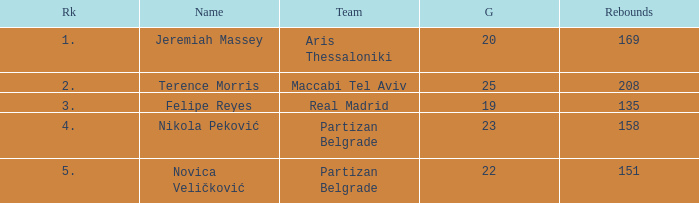How many Rebounds did Novica Veličković get in less than 22 Games? None. 